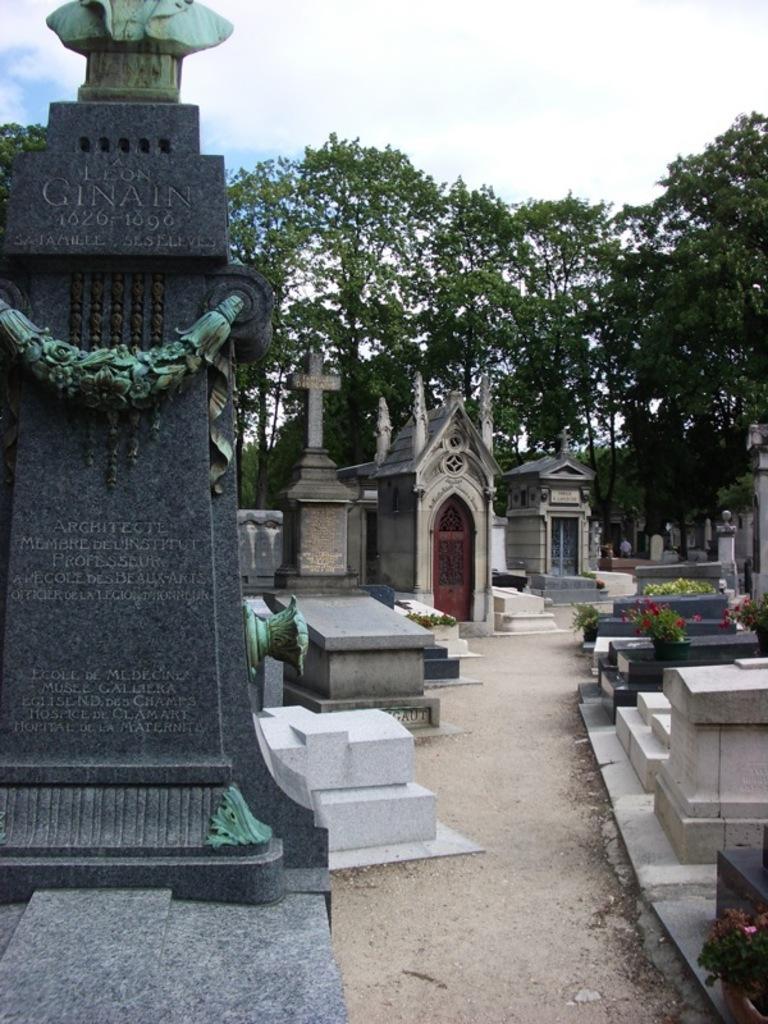Can you describe this image briefly? In this image we can see the view of grave yard in which there are some headstones, gravestones and in the background of the image there are some trees and clear sky. 